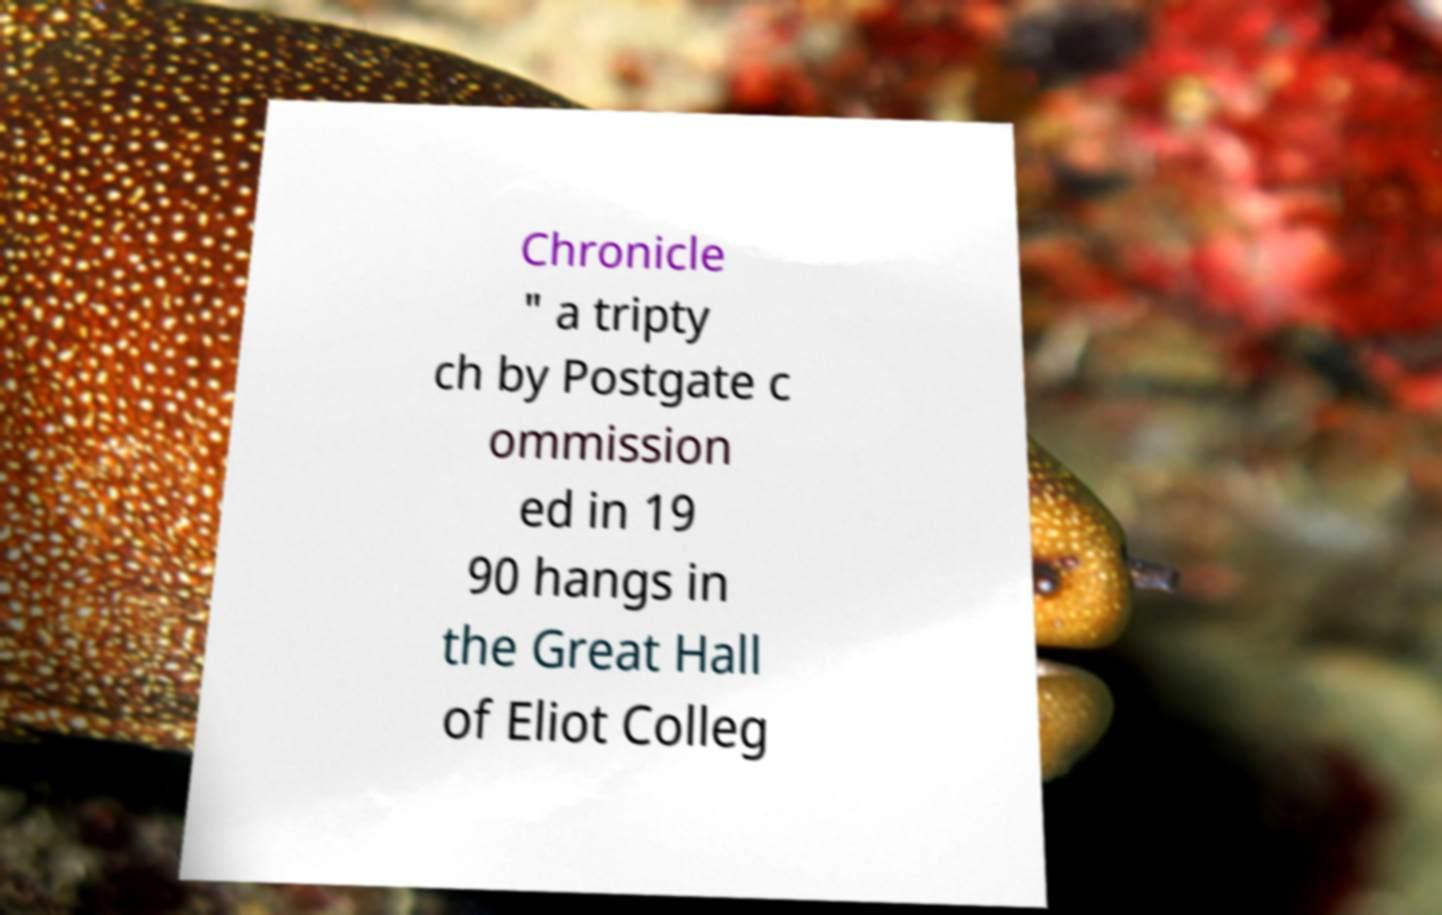There's text embedded in this image that I need extracted. Can you transcribe it verbatim? Chronicle " a tripty ch by Postgate c ommission ed in 19 90 hangs in the Great Hall of Eliot Colleg 